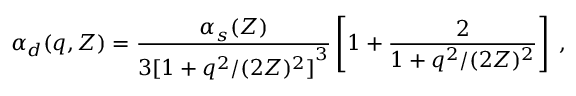<formula> <loc_0><loc_0><loc_500><loc_500>\alpha _ { d } ( q , Z ) = \frac { \alpha _ { s } ( Z ) } { { 3 [ 1 + q ^ { 2 } / ( 2 Z ) ^ { 2 } ] } ^ { 3 } } \left [ 1 + \frac { 2 } { 1 + q ^ { 2 } / ( 2 Z ) ^ { 2 } } \right ] \, ,</formula> 